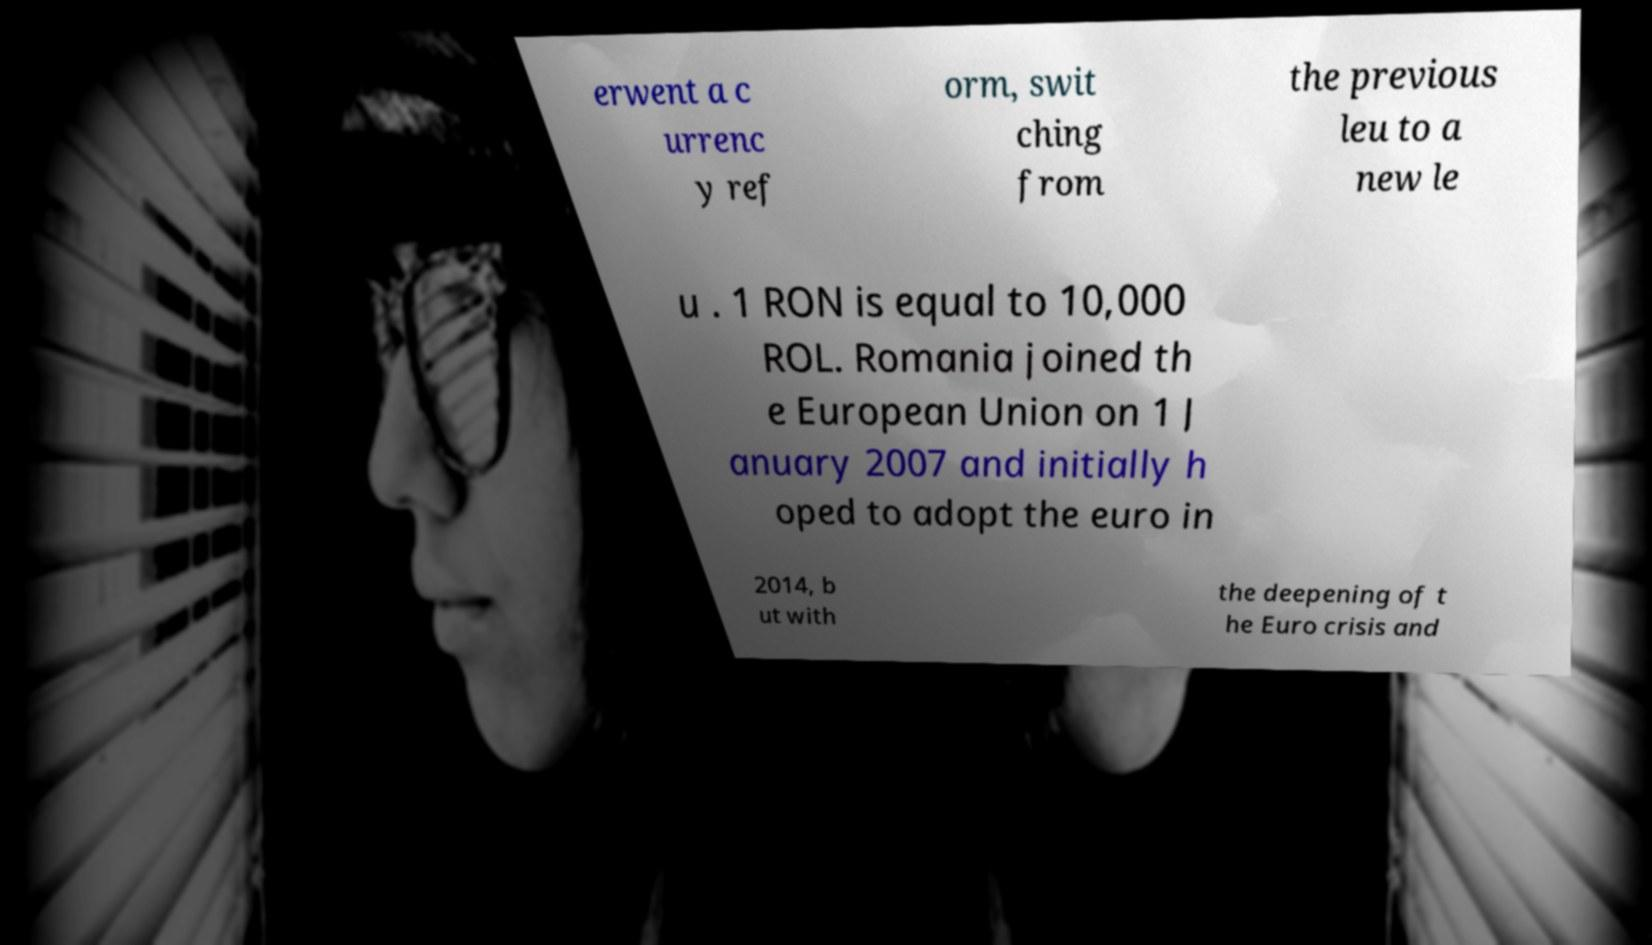Could you assist in decoding the text presented in this image and type it out clearly? erwent a c urrenc y ref orm, swit ching from the previous leu to a new le u . 1 RON is equal to 10,000 ROL. Romania joined th e European Union on 1 J anuary 2007 and initially h oped to adopt the euro in 2014, b ut with the deepening of t he Euro crisis and 